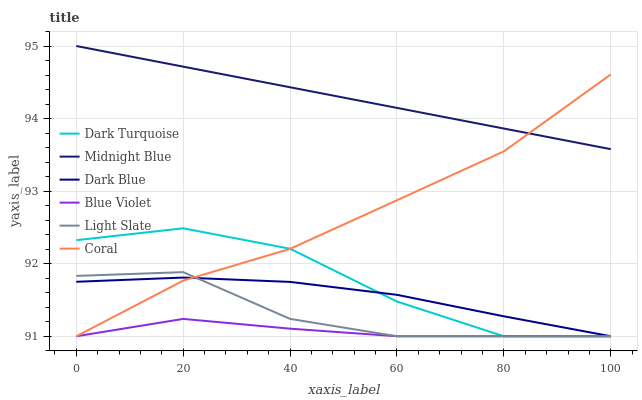Does Blue Violet have the minimum area under the curve?
Answer yes or no. Yes. Does Midnight Blue have the maximum area under the curve?
Answer yes or no. Yes. Does Light Slate have the minimum area under the curve?
Answer yes or no. No. Does Light Slate have the maximum area under the curve?
Answer yes or no. No. Is Midnight Blue the smoothest?
Answer yes or no. Yes. Is Dark Turquoise the roughest?
Answer yes or no. Yes. Is Light Slate the smoothest?
Answer yes or no. No. Is Light Slate the roughest?
Answer yes or no. No. Does Light Slate have the lowest value?
Answer yes or no. Yes. Does Midnight Blue have the highest value?
Answer yes or no. Yes. Does Light Slate have the highest value?
Answer yes or no. No. Is Dark Turquoise less than Midnight Blue?
Answer yes or no. Yes. Is Midnight Blue greater than Light Slate?
Answer yes or no. Yes. Does Midnight Blue intersect Coral?
Answer yes or no. Yes. Is Midnight Blue less than Coral?
Answer yes or no. No. Is Midnight Blue greater than Coral?
Answer yes or no. No. Does Dark Turquoise intersect Midnight Blue?
Answer yes or no. No. 